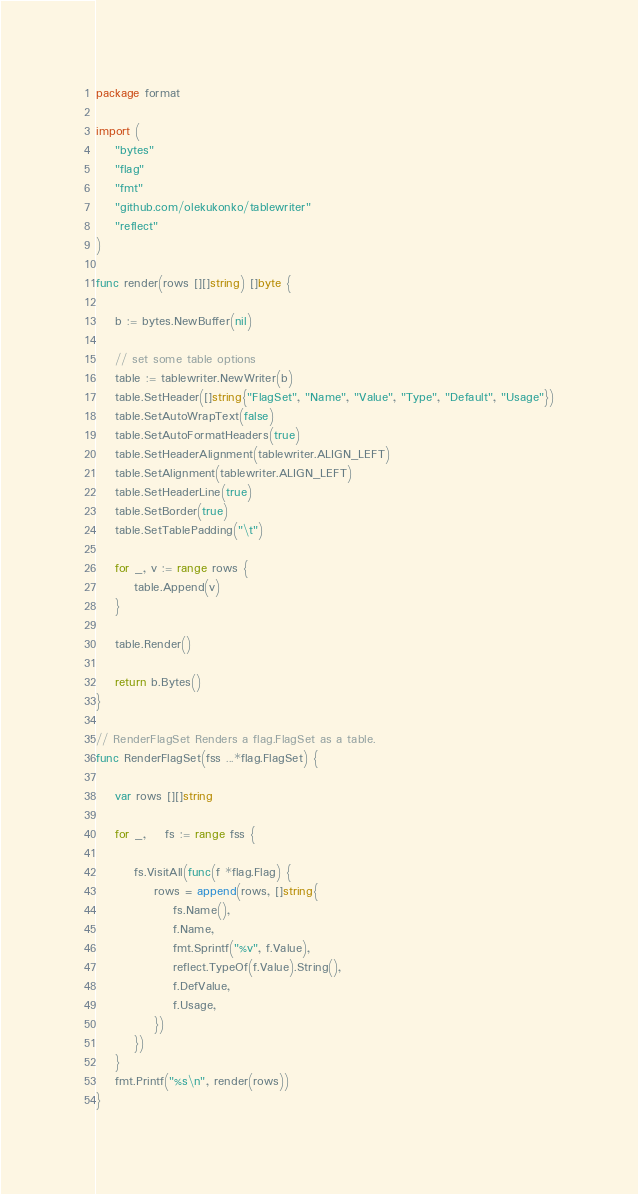<code> <loc_0><loc_0><loc_500><loc_500><_Go_>package format

import (
	"bytes"
	"flag"
	"fmt"
	"github.com/olekukonko/tablewriter"
	"reflect"
)

func render(rows [][]string) []byte {

	b := bytes.NewBuffer(nil)

	// set some table options
	table := tablewriter.NewWriter(b)
	table.SetHeader([]string{"FlagSet", "Name", "Value", "Type", "Default", "Usage"})
	table.SetAutoWrapText(false)
	table.SetAutoFormatHeaders(true)
	table.SetHeaderAlignment(tablewriter.ALIGN_LEFT)
	table.SetAlignment(tablewriter.ALIGN_LEFT)
	table.SetHeaderLine(true)
	table.SetBorder(true)
	table.SetTablePadding("\t")

	for _, v := range rows {
		table.Append(v)
	}

	table.Render()

	return b.Bytes()
}

// RenderFlagSet Renders a flag.FlagSet as a table.
func RenderFlagSet(fss ...*flag.FlagSet) {

	var rows [][]string

	for _, 	fs := range fss {

		fs.VisitAll(func(f *flag.Flag) {
			rows = append(rows, []string{
				fs.Name(),
				f.Name,
				fmt.Sprintf("%v", f.Value),
				reflect.TypeOf(f.Value).String(),
				f.DefValue,
				f.Usage,
			})
		})
	}
	fmt.Printf("%s\n", render(rows))
}</code> 